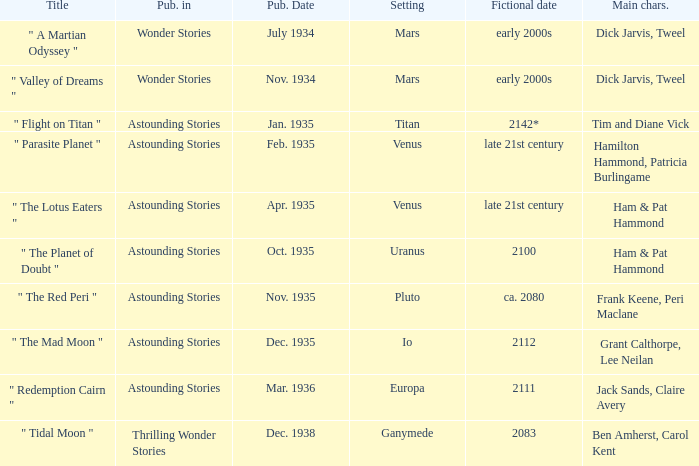Name the title when the main characters are grant calthorpe, lee neilan and the published in of astounding stories " The Mad Moon ". 